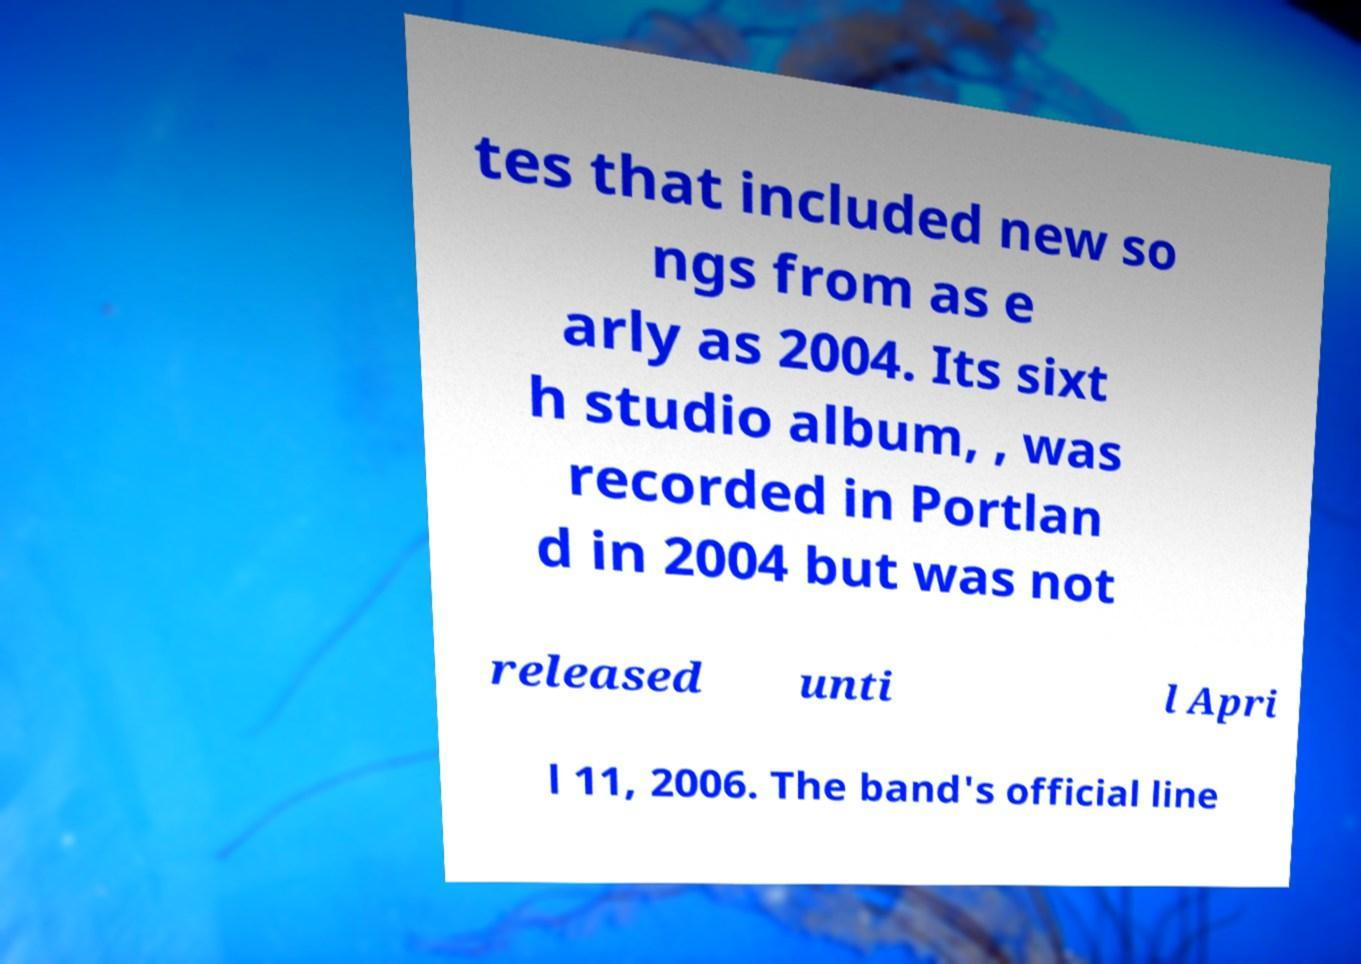Could you extract and type out the text from this image? tes that included new so ngs from as e arly as 2004. Its sixt h studio album, , was recorded in Portlan d in 2004 but was not released unti l Apri l 11, 2006. The band's official line 